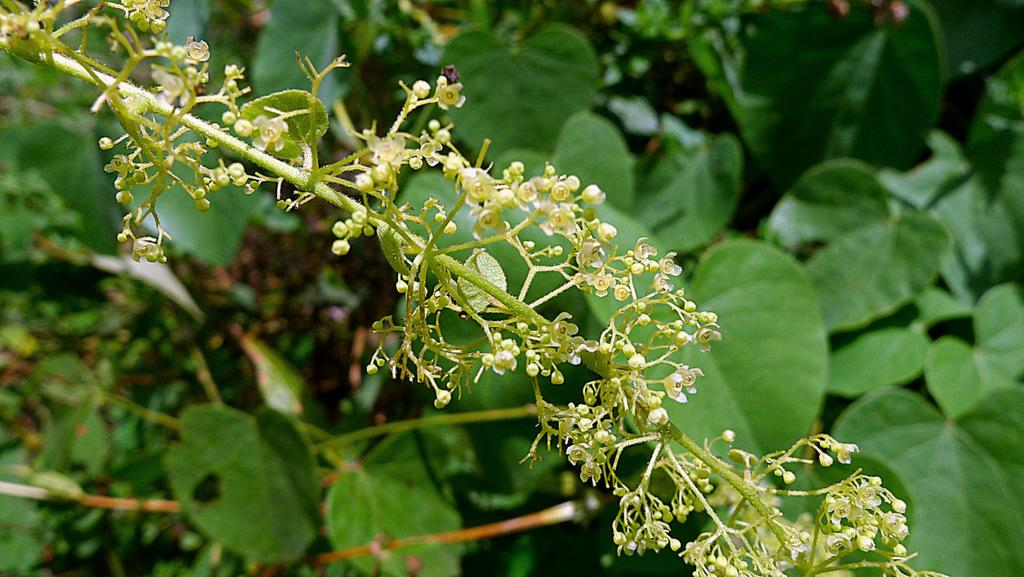What color are the leaves in the image? The leaves in the image are green. What else can be seen in the image besides the leaves? There are green stems in the image. What type of jeans can be seen in the image? There are no jeans present in the image; it only features green leaves and stems. What scent is associated with the image? There is no scent associated with the image; it is a visual representation of green leaves and stems. 